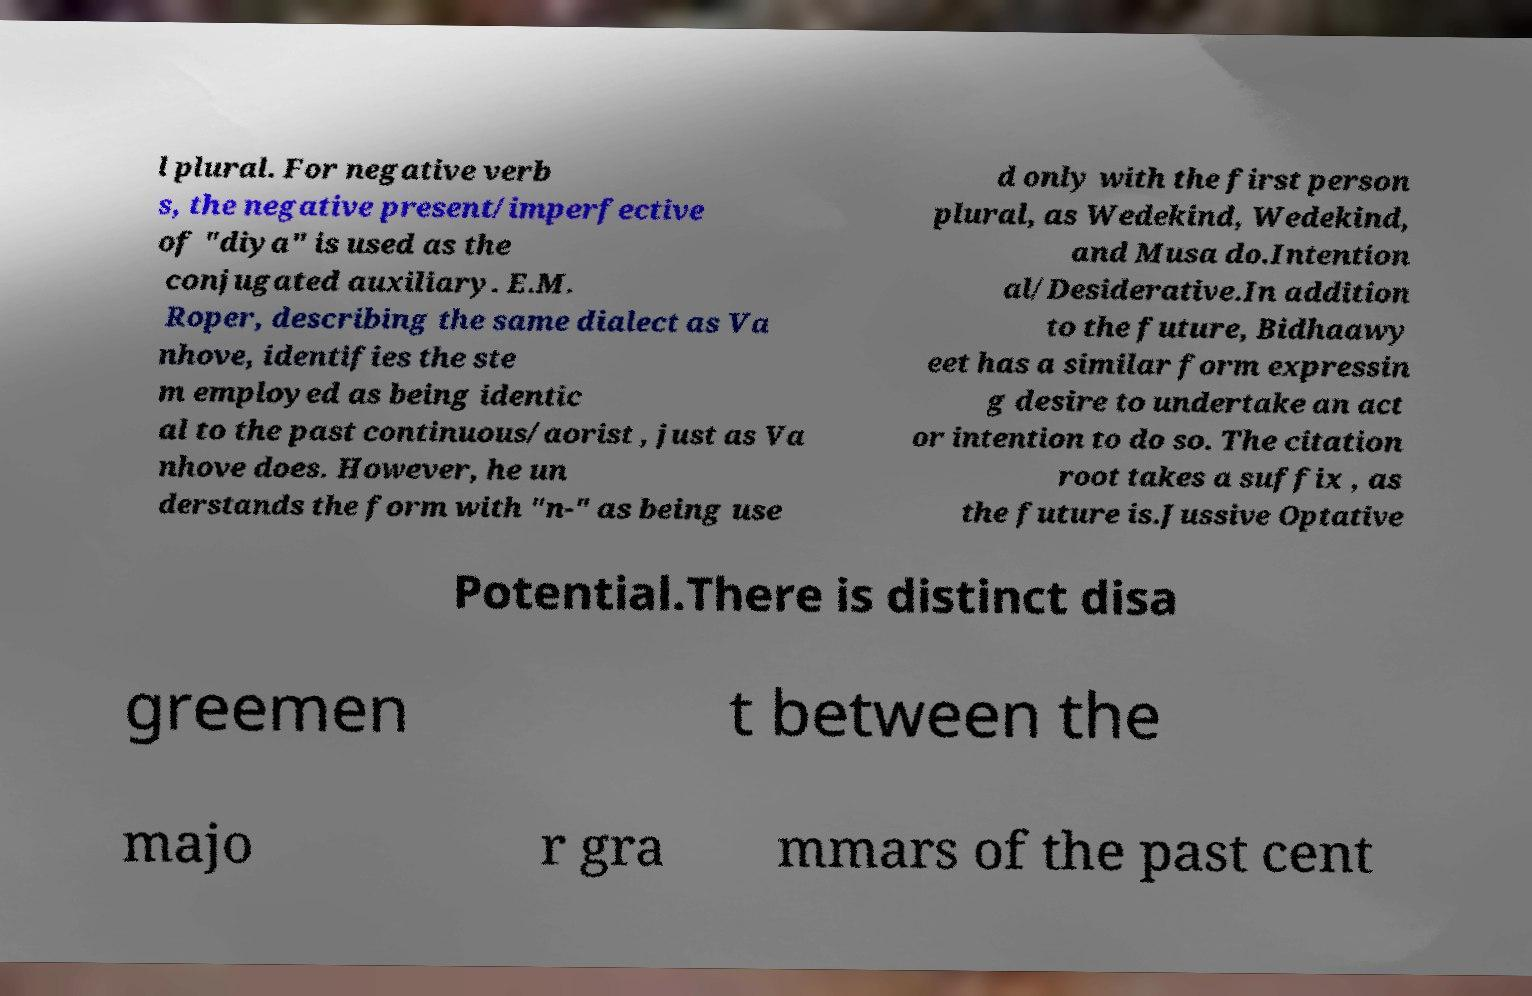I need the written content from this picture converted into text. Can you do that? l plural. For negative verb s, the negative present/imperfective of "diya" is used as the conjugated auxiliary. E.M. Roper, describing the same dialect as Va nhove, identifies the ste m employed as being identic al to the past continuous/aorist , just as Va nhove does. However, he un derstands the form with "n-" as being use d only with the first person plural, as Wedekind, Wedekind, and Musa do.Intention al/Desiderative.In addition to the future, Bidhaawy eet has a similar form expressin g desire to undertake an act or intention to do so. The citation root takes a suffix , as the future is.Jussive Optative Potential.There is distinct disa greemen t between the majo r gra mmars of the past cent 